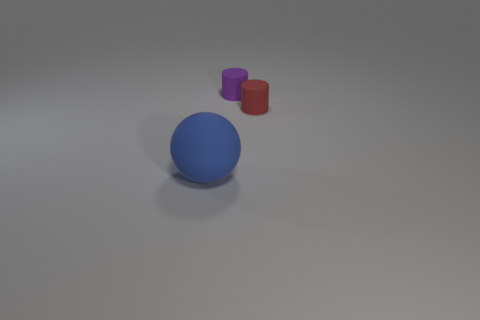There is a small cylinder that is on the right side of the tiny purple rubber cylinder; what color is it?
Your answer should be compact. Red. Do the small purple thing and the matte thing in front of the red rubber cylinder have the same shape?
Your answer should be compact. No. Is there another big shiny sphere that has the same color as the ball?
Offer a terse response. No. There is a red cylinder that is made of the same material as the tiny purple cylinder; what is its size?
Your response must be concise. Small. There is a small rubber object that is right of the purple rubber thing; is its shape the same as the large rubber object?
Provide a short and direct response. No. How many red matte cylinders have the same size as the red thing?
Provide a short and direct response. 0. There is a small object left of the red cylinder; are there any tiny red cylinders that are behind it?
Your answer should be very brief. No. What number of objects are small rubber things that are on the left side of the red thing or blue things?
Provide a short and direct response. 2. How many tiny things are there?
Give a very brief answer. 2. What shape is the tiny purple thing that is the same material as the big blue sphere?
Offer a very short reply. Cylinder. 